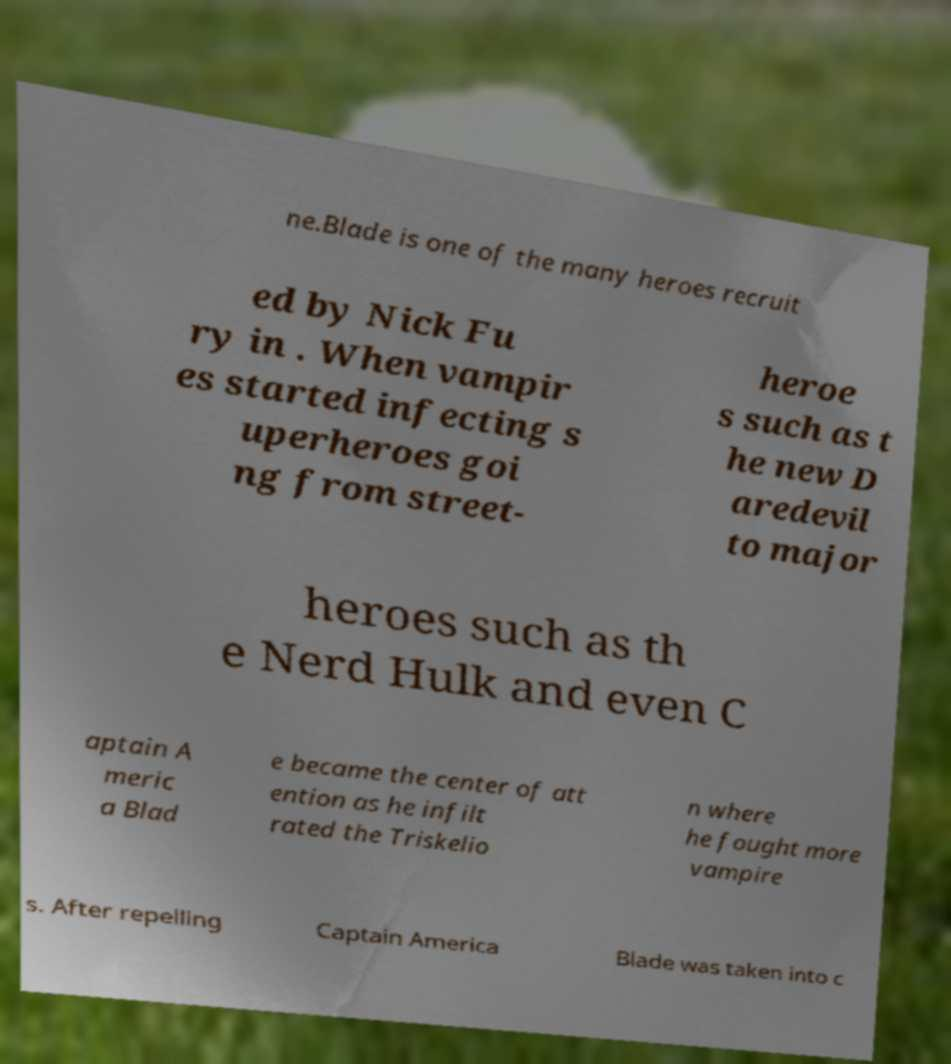There's text embedded in this image that I need extracted. Can you transcribe it verbatim? ne.Blade is one of the many heroes recruit ed by Nick Fu ry in . When vampir es started infecting s uperheroes goi ng from street- heroe s such as t he new D aredevil to major heroes such as th e Nerd Hulk and even C aptain A meric a Blad e became the center of att ention as he infilt rated the Triskelio n where he fought more vampire s. After repelling Captain America Blade was taken into c 